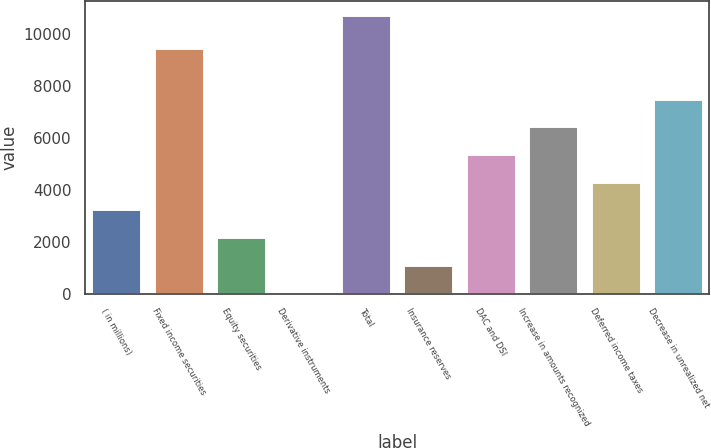Convert chart to OTSL. <chart><loc_0><loc_0><loc_500><loc_500><bar_chart><fcel>( in millions)<fcel>Fixed income securities<fcel>Equity securities<fcel>Derivative instruments<fcel>Total<fcel>Insurance reserves<fcel>DAC and DSI<fcel>Increase in amounts recognized<fcel>Deferred income taxes<fcel>Decrease in unrealized net<nl><fcel>3248.9<fcel>9452<fcel>2180.6<fcel>44<fcel>10727<fcel>1112.3<fcel>5385.5<fcel>6453.8<fcel>4317.2<fcel>7522.1<nl></chart> 